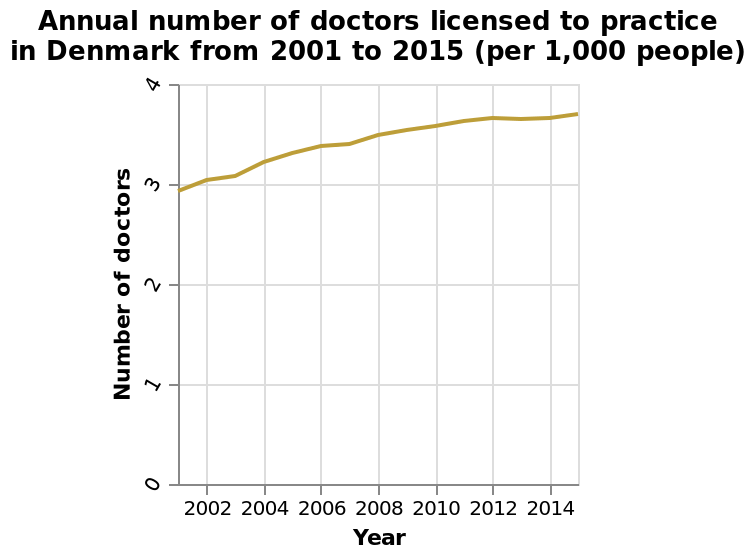<image>
please summary the statistics and relations of the chart Since 2002 the number of licensed doctors to practice has increased over the years. What is the range of the y-axis on the graph?  The range of the y-axis on the graph is from 0 to 4. please enumerates aspects of the construction of the chart Annual number of doctors licensed to practice in Denmark from 2001 to 2015 (per 1,000 people) is a line graph. The y-axis plots Number of doctors using a linear scale with a minimum of 0 and a maximum of 4. There is a linear scale with a minimum of 2002 and a maximum of 2014 along the x-axis, labeled Year. How did the number of doctors licensed to practice in Denmark change between 2002 and 2014? The number of doctors licensed to practice in Denmark grew steadily during that period. 